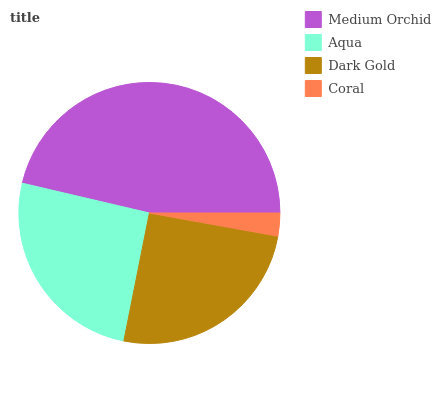Is Coral the minimum?
Answer yes or no. Yes. Is Medium Orchid the maximum?
Answer yes or no. Yes. Is Aqua the minimum?
Answer yes or no. No. Is Aqua the maximum?
Answer yes or no. No. Is Medium Orchid greater than Aqua?
Answer yes or no. Yes. Is Aqua less than Medium Orchid?
Answer yes or no. Yes. Is Aqua greater than Medium Orchid?
Answer yes or no. No. Is Medium Orchid less than Aqua?
Answer yes or no. No. Is Aqua the high median?
Answer yes or no. Yes. Is Dark Gold the low median?
Answer yes or no. Yes. Is Medium Orchid the high median?
Answer yes or no. No. Is Aqua the low median?
Answer yes or no. No. 